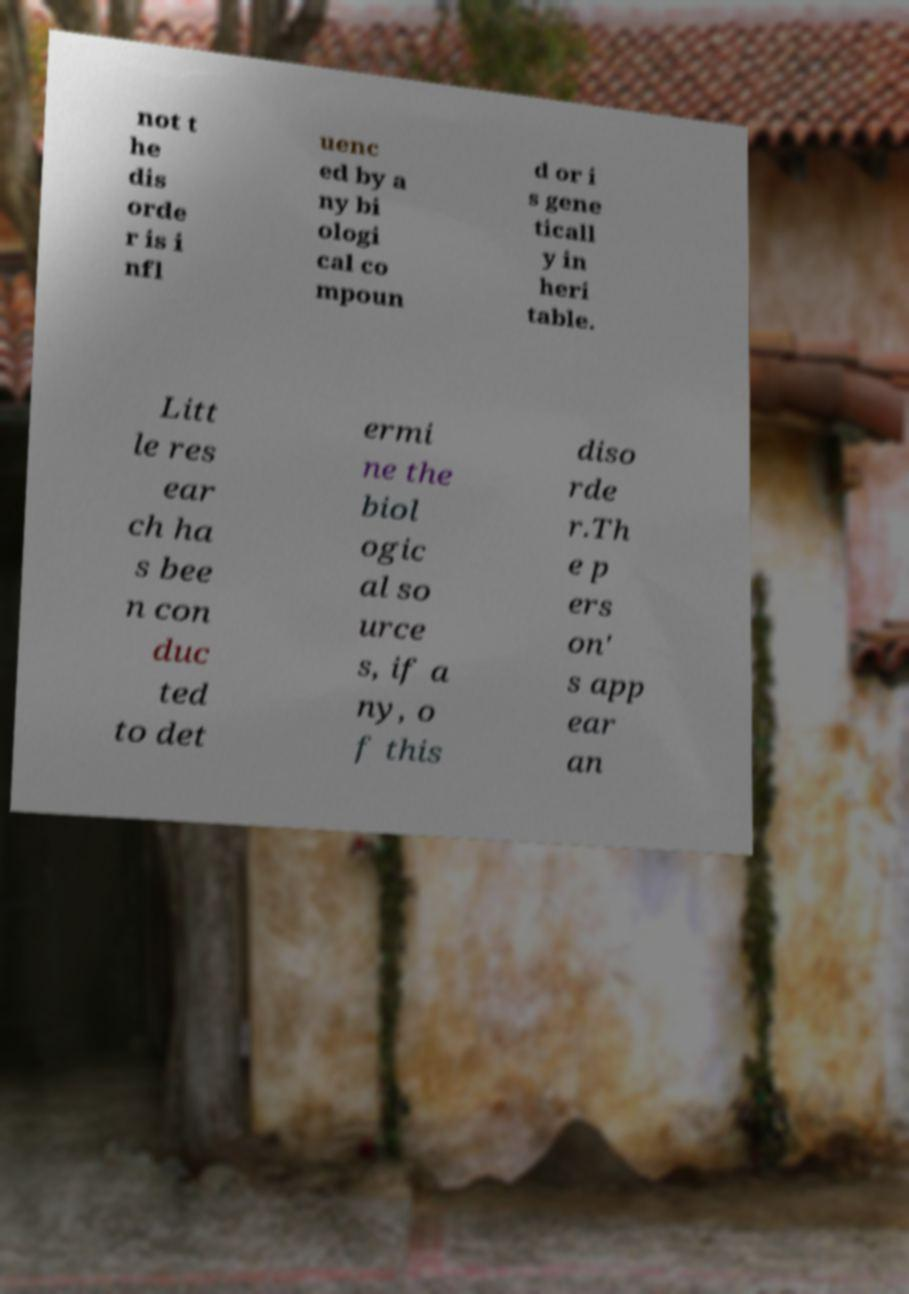Could you assist in decoding the text presented in this image and type it out clearly? not t he dis orde r is i nfl uenc ed by a ny bi ologi cal co mpoun d or i s gene ticall y in heri table. Litt le res ear ch ha s bee n con duc ted to det ermi ne the biol ogic al so urce s, if a ny, o f this diso rde r.Th e p ers on' s app ear an 